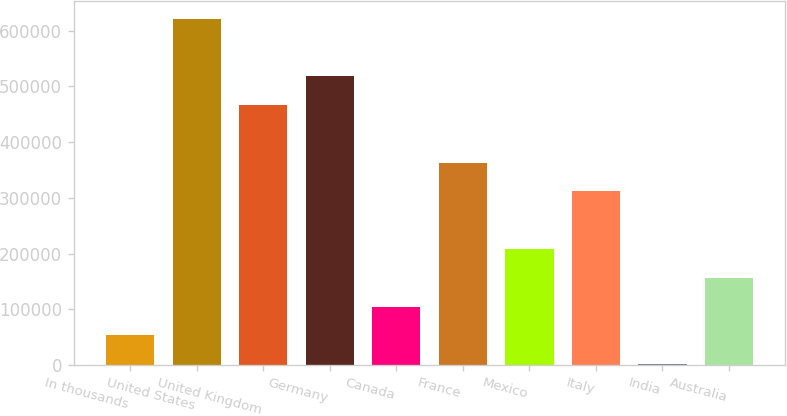Convert chart to OTSL. <chart><loc_0><loc_0><loc_500><loc_500><bar_chart><fcel>In thousands<fcel>United States<fcel>United Kingdom<fcel>Germany<fcel>Canada<fcel>France<fcel>Mexico<fcel>Italy<fcel>India<fcel>Australia<nl><fcel>52981.5<fcel>621797<fcel>466666<fcel>518376<fcel>104692<fcel>363244<fcel>208113<fcel>311534<fcel>1271<fcel>156402<nl></chart> 